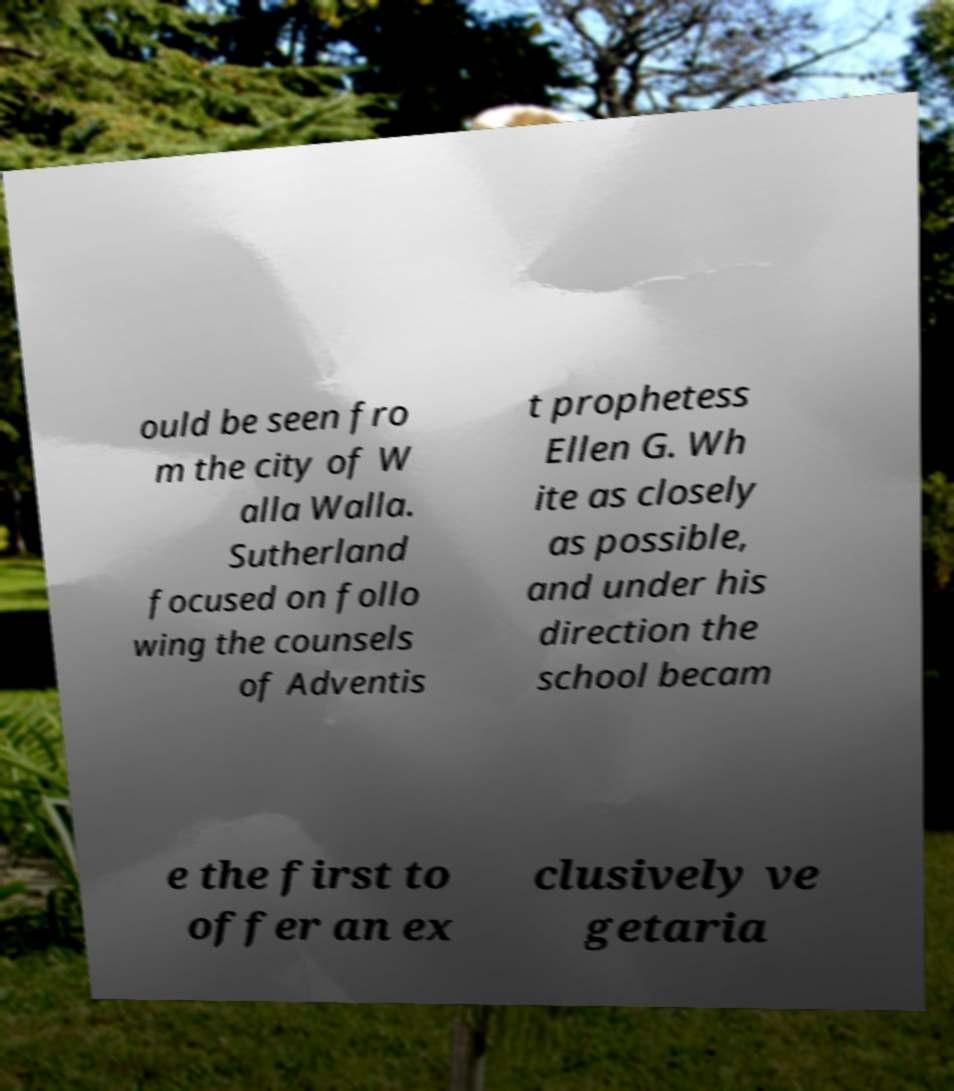Please read and relay the text visible in this image. What does it say? ould be seen fro m the city of W alla Walla. Sutherland focused on follo wing the counsels of Adventis t prophetess Ellen G. Wh ite as closely as possible, and under his direction the school becam e the first to offer an ex clusively ve getaria 